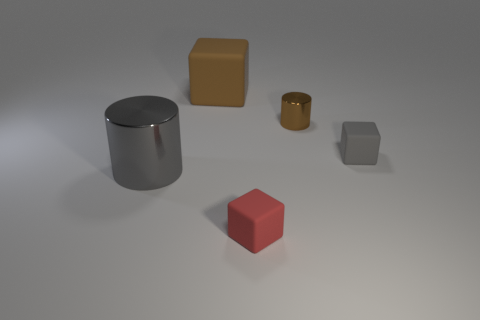Add 5 big gray cylinders. How many objects exist? 10 Subtract all cubes. How many objects are left? 2 Add 3 red objects. How many red objects exist? 4 Subtract 0 gray balls. How many objects are left? 5 Subtract all tiny brown cylinders. Subtract all tiny red rubber cubes. How many objects are left? 3 Add 3 small cubes. How many small cubes are left? 5 